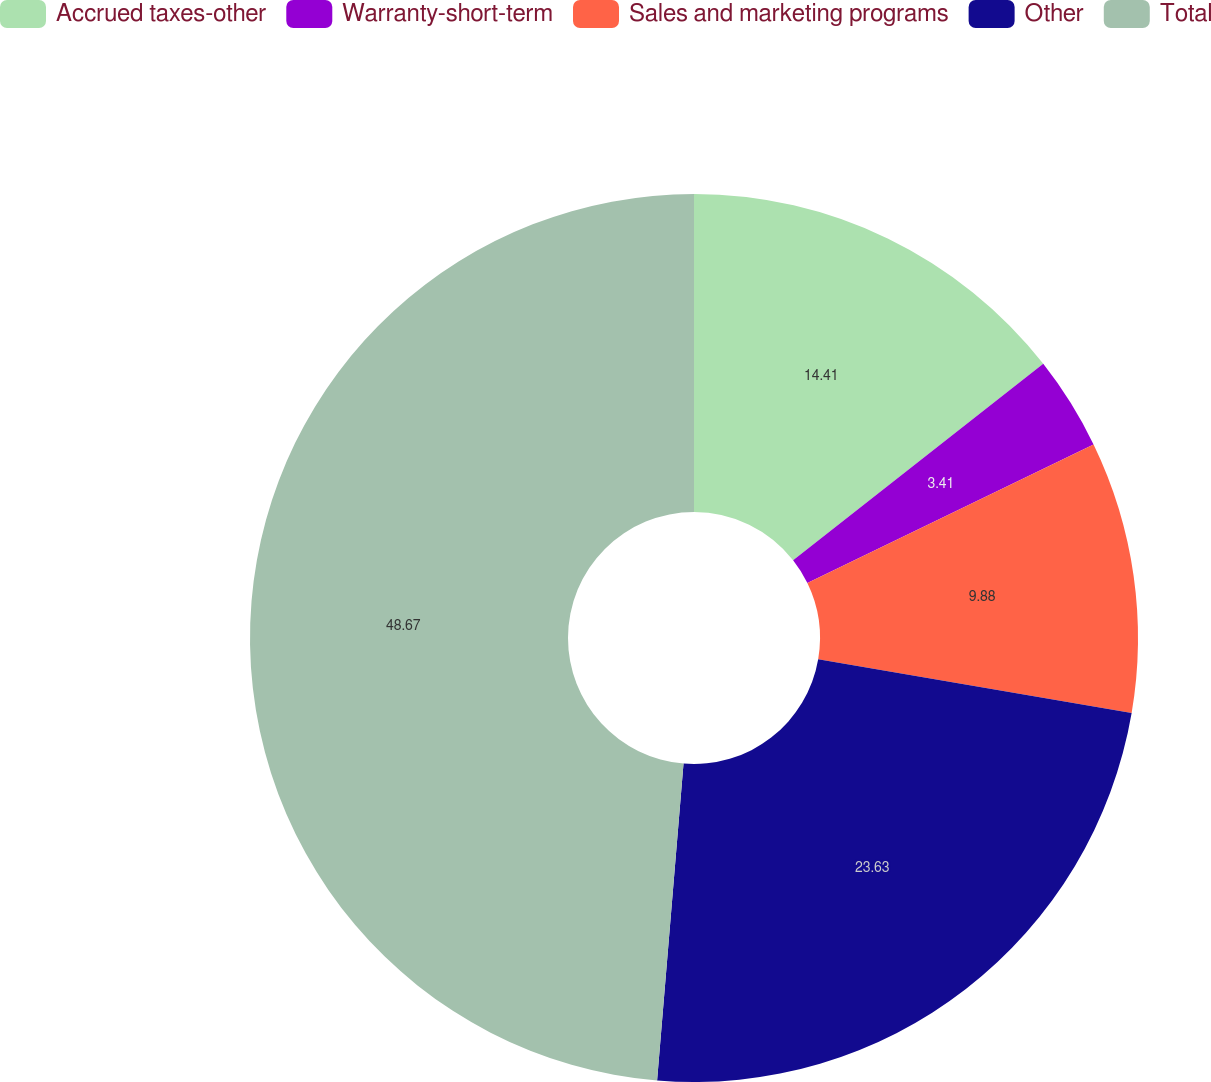Convert chart. <chart><loc_0><loc_0><loc_500><loc_500><pie_chart><fcel>Accrued taxes-other<fcel>Warranty-short-term<fcel>Sales and marketing programs<fcel>Other<fcel>Total<nl><fcel>14.41%<fcel>3.41%<fcel>9.88%<fcel>23.63%<fcel>48.68%<nl></chart> 